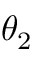<formula> <loc_0><loc_0><loc_500><loc_500>\theta _ { 2 }</formula> 